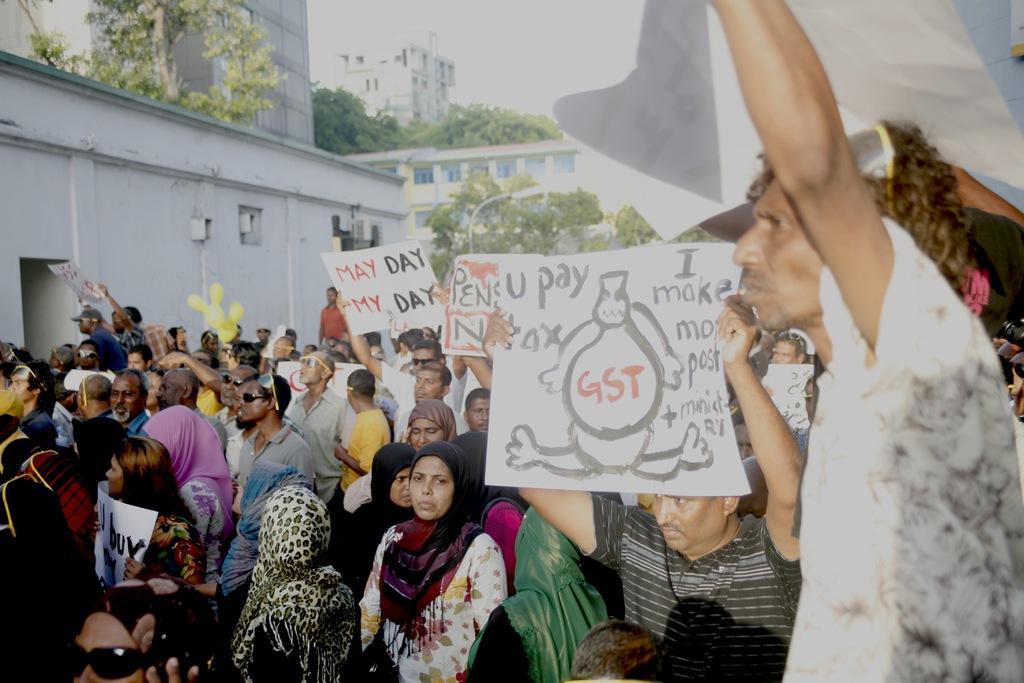How would you summarize this image in a sentence or two? In this image there are few persons holding boards in their hands. Few persons are standing. There are few women wearing scarfs. Few persons are wearing goggles. Behind them there are few trees and buildings. Top of image there is sky. 